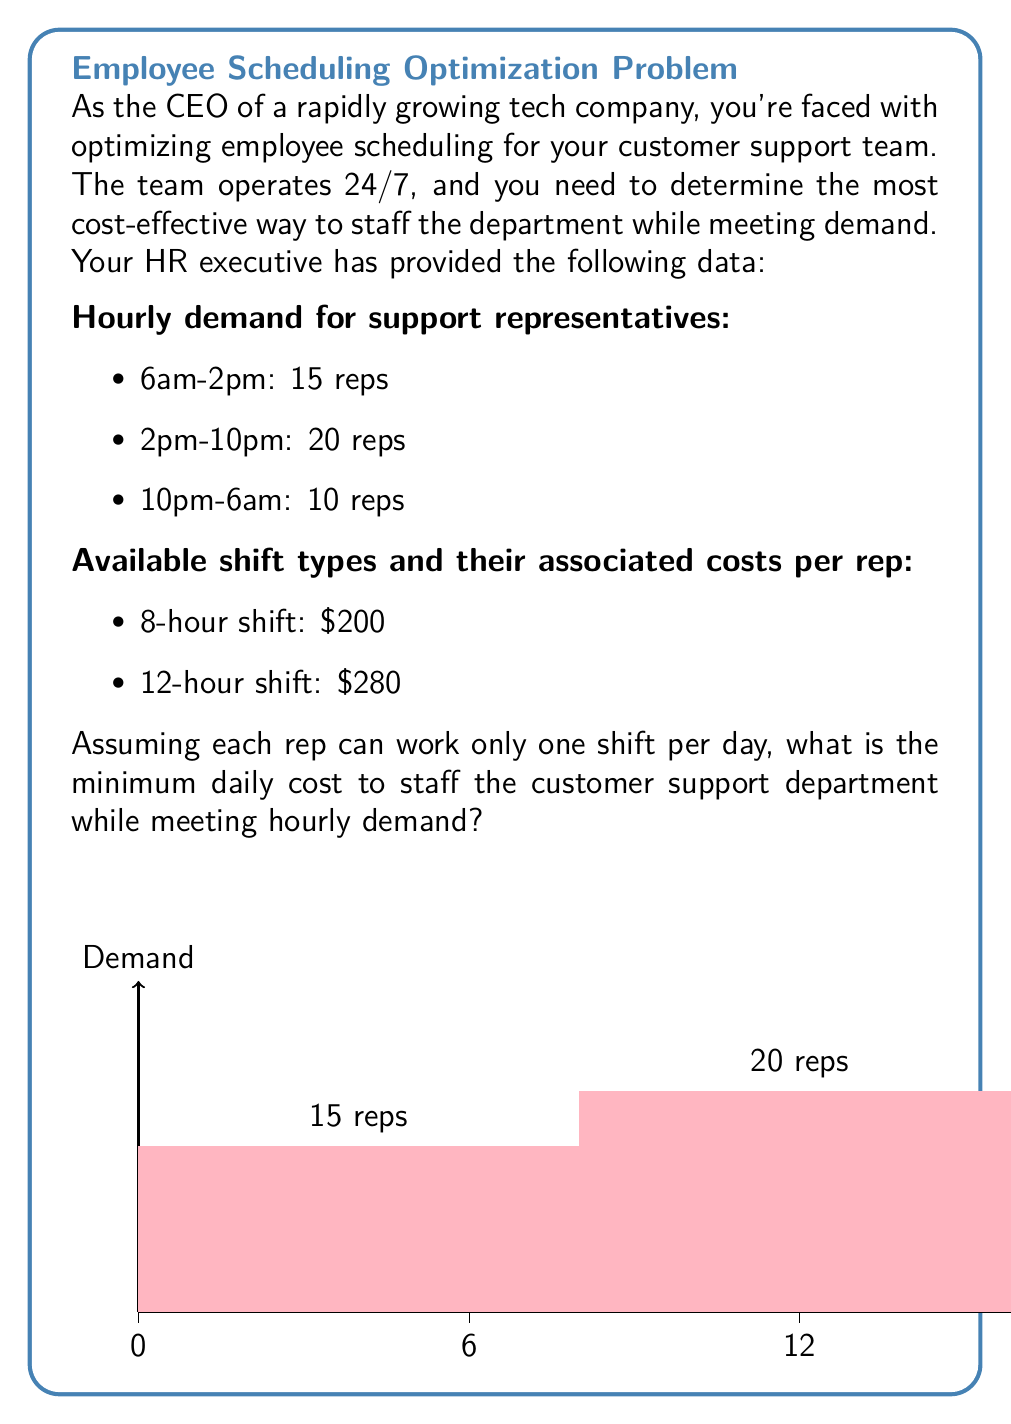Can you answer this question? Let's approach this problem step-by-step using linear programming:

1) Define variables:
   Let $x_1$ = number of 8-hour shifts
   Let $x_2$ = number of 12-hour shifts

2) Objective function:
   Minimize $Z = 200x_1 + 280x_2$

3) Constraints:
   For 6am-2pm (8 hours): $x_1 + x_2 \geq 15$
   For 2pm-10pm (8 hours): $x_1 + x_2 \geq 20$
   For 10pm-6am (8 hours): $x_1 + x_2 \geq 10$

   Non-negativity: $x_1, x_2 \geq 0$

4) Simplify constraints:
   The binding constraint is $x_1 + x_2 \geq 20$, as it covers the peak demand.

5) Solve graphically or using the simplex method:
   The optimal solution occurs at the corner point $(20, 0)$, meaning 20 8-hour shifts and 0 12-hour shifts.

6) Calculate the minimum cost:
   $Z = 200(20) + 280(0) = 4000$

Therefore, the minimum daily cost to staff the customer support department while meeting hourly demand is $4000.

This solution uses twenty 8-hour shifts, which can be distributed as follows:
- 7 shifts from 6am-2pm
- 8 shifts from 2pm-10pm
- 5 shifts from 10pm-6am

This distribution meets or exceeds the demand for each time period while minimizing costs.
Answer: $4000 